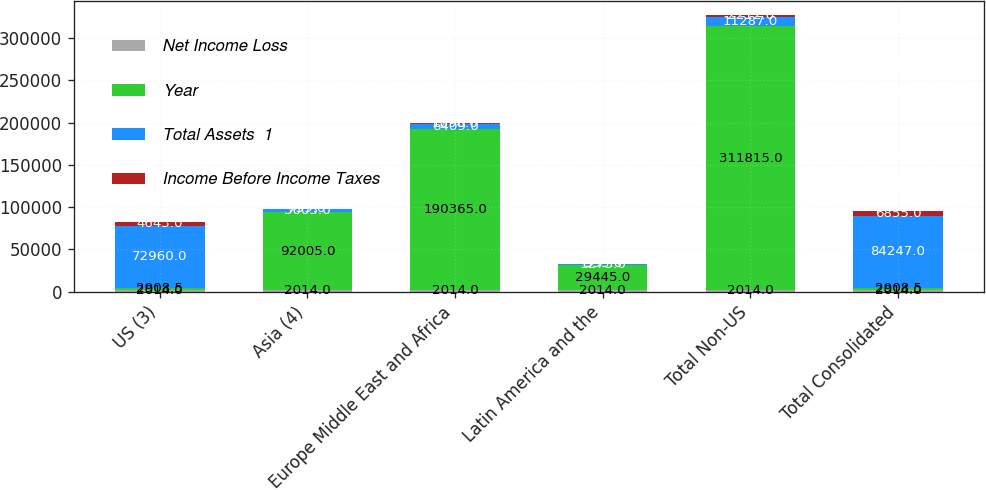Convert chart. <chart><loc_0><loc_0><loc_500><loc_500><stacked_bar_chart><ecel><fcel>US (3)<fcel>Asia (4)<fcel>Europe Middle East and Africa<fcel>Latin America and the<fcel>Total Non-US<fcel>Total Consolidated<nl><fcel>Net Income Loss<fcel>2014<fcel>2014<fcel>2014<fcel>2014<fcel>2014<fcel>2014<nl><fcel>Year<fcel>2908.5<fcel>92005<fcel>190365<fcel>29445<fcel>311815<fcel>2908.5<nl><fcel>Total Assets  1<fcel>72960<fcel>3605<fcel>6409<fcel>1273<fcel>11287<fcel>84247<nl><fcel>Income Before Income Taxes<fcel>4643<fcel>759<fcel>1098<fcel>355<fcel>2212<fcel>6855<nl></chart> 